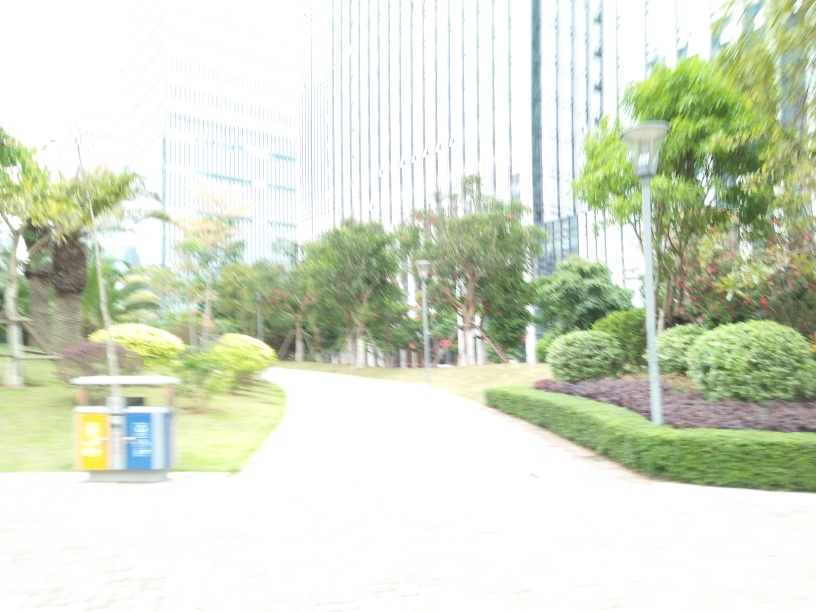What time of day does this photo seem to be taken? Although the overexposure obscures some details, the lighting suggests it could be taken during midday when the sun is at its brightest. 